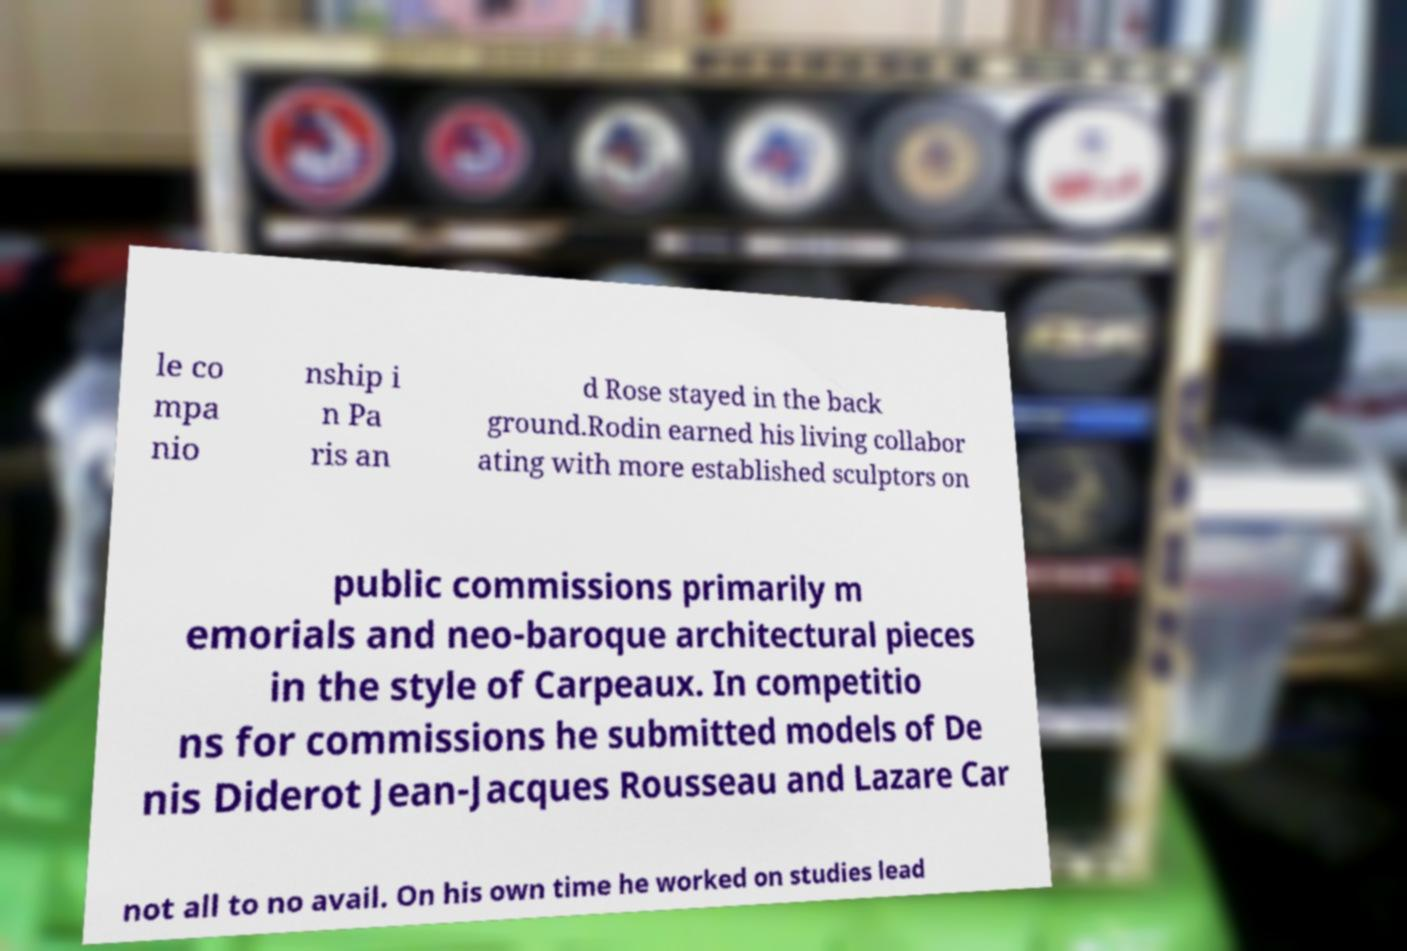Could you assist in decoding the text presented in this image and type it out clearly? le co mpa nio nship i n Pa ris an d Rose stayed in the back ground.Rodin earned his living collabor ating with more established sculptors on public commissions primarily m emorials and neo-baroque architectural pieces in the style of Carpeaux. In competitio ns for commissions he submitted models of De nis Diderot Jean-Jacques Rousseau and Lazare Car not all to no avail. On his own time he worked on studies lead 